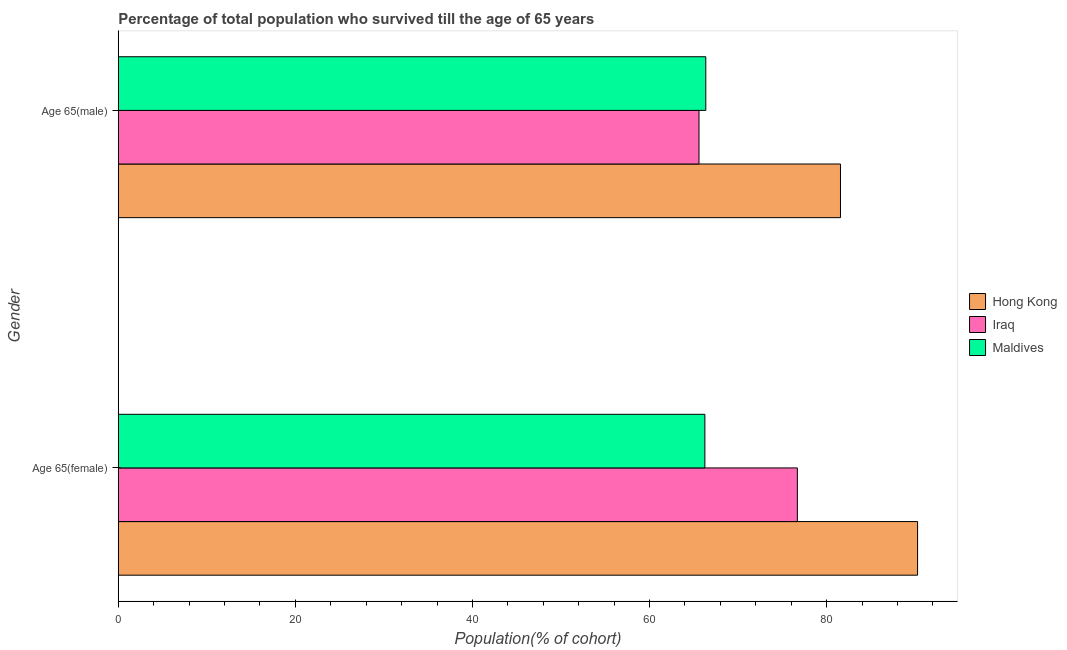How many different coloured bars are there?
Provide a succinct answer. 3. How many groups of bars are there?
Offer a terse response. 2. Are the number of bars per tick equal to the number of legend labels?
Your answer should be very brief. Yes. What is the label of the 2nd group of bars from the top?
Offer a very short reply. Age 65(female). What is the percentage of female population who survived till age of 65 in Maldives?
Ensure brevity in your answer.  66.25. Across all countries, what is the maximum percentage of female population who survived till age of 65?
Ensure brevity in your answer.  90.27. Across all countries, what is the minimum percentage of male population who survived till age of 65?
Ensure brevity in your answer.  65.58. In which country was the percentage of male population who survived till age of 65 maximum?
Offer a terse response. Hong Kong. In which country was the percentage of male population who survived till age of 65 minimum?
Ensure brevity in your answer.  Iraq. What is the total percentage of male population who survived till age of 65 in the graph?
Your response must be concise. 213.5. What is the difference between the percentage of female population who survived till age of 65 in Maldives and that in Iraq?
Your answer should be compact. -10.45. What is the difference between the percentage of female population who survived till age of 65 in Iraq and the percentage of male population who survived till age of 65 in Hong Kong?
Offer a very short reply. -4.87. What is the average percentage of male population who survived till age of 65 per country?
Offer a very short reply. 71.17. What is the difference between the percentage of male population who survived till age of 65 and percentage of female population who survived till age of 65 in Iraq?
Give a very brief answer. -11.11. In how many countries, is the percentage of female population who survived till age of 65 greater than 8 %?
Ensure brevity in your answer.  3. What is the ratio of the percentage of male population who survived till age of 65 in Iraq to that in Hong Kong?
Your response must be concise. 0.8. What does the 2nd bar from the top in Age 65(male) represents?
Offer a terse response. Iraq. What does the 2nd bar from the bottom in Age 65(male) represents?
Your answer should be compact. Iraq. How many bars are there?
Make the answer very short. 6. Are the values on the major ticks of X-axis written in scientific E-notation?
Provide a short and direct response. No. Does the graph contain any zero values?
Keep it short and to the point. No. Where does the legend appear in the graph?
Your response must be concise. Center right. How many legend labels are there?
Your answer should be compact. 3. How are the legend labels stacked?
Your answer should be compact. Vertical. What is the title of the graph?
Offer a terse response. Percentage of total population who survived till the age of 65 years. What is the label or title of the X-axis?
Your answer should be compact. Population(% of cohort). What is the label or title of the Y-axis?
Your response must be concise. Gender. What is the Population(% of cohort) in Hong Kong in Age 65(female)?
Provide a short and direct response. 90.27. What is the Population(% of cohort) in Iraq in Age 65(female)?
Your response must be concise. 76.69. What is the Population(% of cohort) in Maldives in Age 65(female)?
Offer a very short reply. 66.25. What is the Population(% of cohort) in Hong Kong in Age 65(male)?
Your response must be concise. 81.56. What is the Population(% of cohort) in Iraq in Age 65(male)?
Give a very brief answer. 65.58. What is the Population(% of cohort) in Maldives in Age 65(male)?
Offer a very short reply. 66.35. Across all Gender, what is the maximum Population(% of cohort) of Hong Kong?
Provide a succinct answer. 90.27. Across all Gender, what is the maximum Population(% of cohort) in Iraq?
Your response must be concise. 76.69. Across all Gender, what is the maximum Population(% of cohort) in Maldives?
Your response must be concise. 66.35. Across all Gender, what is the minimum Population(% of cohort) in Hong Kong?
Your response must be concise. 81.56. Across all Gender, what is the minimum Population(% of cohort) of Iraq?
Give a very brief answer. 65.58. Across all Gender, what is the minimum Population(% of cohort) in Maldives?
Provide a succinct answer. 66.25. What is the total Population(% of cohort) of Hong Kong in the graph?
Make the answer very short. 171.83. What is the total Population(% of cohort) in Iraq in the graph?
Provide a succinct answer. 142.28. What is the total Population(% of cohort) in Maldives in the graph?
Offer a very short reply. 132.6. What is the difference between the Population(% of cohort) in Hong Kong in Age 65(female) and that in Age 65(male)?
Ensure brevity in your answer.  8.71. What is the difference between the Population(% of cohort) of Iraq in Age 65(female) and that in Age 65(male)?
Your response must be concise. 11.11. What is the difference between the Population(% of cohort) of Maldives in Age 65(female) and that in Age 65(male)?
Offer a terse response. -0.1. What is the difference between the Population(% of cohort) in Hong Kong in Age 65(female) and the Population(% of cohort) in Iraq in Age 65(male)?
Provide a succinct answer. 24.69. What is the difference between the Population(% of cohort) in Hong Kong in Age 65(female) and the Population(% of cohort) in Maldives in Age 65(male)?
Make the answer very short. 23.92. What is the difference between the Population(% of cohort) of Iraq in Age 65(female) and the Population(% of cohort) of Maldives in Age 65(male)?
Your response must be concise. 10.34. What is the average Population(% of cohort) in Hong Kong per Gender?
Provide a succinct answer. 85.92. What is the average Population(% of cohort) in Iraq per Gender?
Keep it short and to the point. 71.14. What is the average Population(% of cohort) in Maldives per Gender?
Offer a terse response. 66.3. What is the difference between the Population(% of cohort) in Hong Kong and Population(% of cohort) in Iraq in Age 65(female)?
Ensure brevity in your answer.  13.58. What is the difference between the Population(% of cohort) in Hong Kong and Population(% of cohort) in Maldives in Age 65(female)?
Offer a very short reply. 24.02. What is the difference between the Population(% of cohort) in Iraq and Population(% of cohort) in Maldives in Age 65(female)?
Make the answer very short. 10.45. What is the difference between the Population(% of cohort) of Hong Kong and Population(% of cohort) of Iraq in Age 65(male)?
Provide a short and direct response. 15.98. What is the difference between the Population(% of cohort) in Hong Kong and Population(% of cohort) in Maldives in Age 65(male)?
Give a very brief answer. 15.21. What is the difference between the Population(% of cohort) of Iraq and Population(% of cohort) of Maldives in Age 65(male)?
Make the answer very short. -0.77. What is the ratio of the Population(% of cohort) in Hong Kong in Age 65(female) to that in Age 65(male)?
Your response must be concise. 1.11. What is the ratio of the Population(% of cohort) of Iraq in Age 65(female) to that in Age 65(male)?
Offer a very short reply. 1.17. What is the difference between the highest and the second highest Population(% of cohort) in Hong Kong?
Make the answer very short. 8.71. What is the difference between the highest and the second highest Population(% of cohort) in Iraq?
Keep it short and to the point. 11.11. What is the difference between the highest and the second highest Population(% of cohort) in Maldives?
Provide a short and direct response. 0.1. What is the difference between the highest and the lowest Population(% of cohort) in Hong Kong?
Offer a terse response. 8.71. What is the difference between the highest and the lowest Population(% of cohort) of Iraq?
Give a very brief answer. 11.11. What is the difference between the highest and the lowest Population(% of cohort) of Maldives?
Keep it short and to the point. 0.1. 